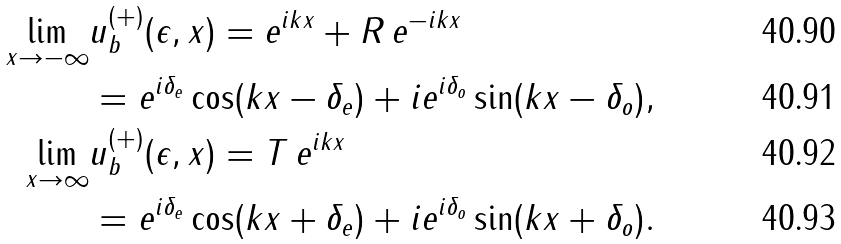Convert formula to latex. <formula><loc_0><loc_0><loc_500><loc_500>\lim _ { x \rightarrow - \infty } & u _ { b } ^ { ( + ) } ( \epsilon , x ) = e ^ { i k x } + R \, e ^ { - i k x } \\ & = e ^ { i \delta _ { e } } \cos ( k x - \delta _ { e } ) + i e ^ { i \delta _ { o } } \sin ( k x - \delta _ { o } ) , \\ \lim _ { x \rightarrow \infty } & u _ { b } ^ { ( + ) } ( \epsilon , x ) = T \, e ^ { i k x } \\ & = e ^ { i \delta _ { e } } \cos ( k x + \delta _ { e } ) + i e ^ { i \delta _ { o } } \sin ( k x + \delta _ { o } ) .</formula> 